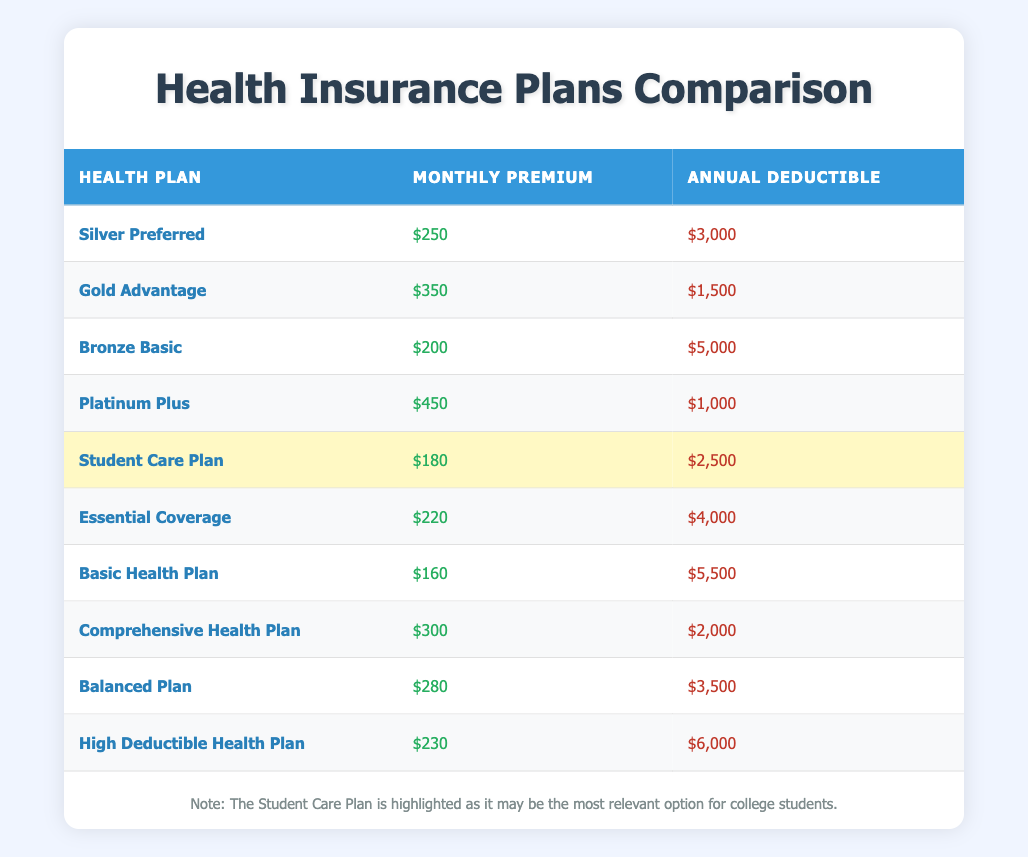What is the monthly premium for the Gold Advantage plan? The Gold Advantage plan has a specific entry in the table that shows its monthly premium, which is clearly listed as $350.
Answer: 350 Which plan has the highest annual deductible? The table provides a listing of all plans along with their annual deductibles. The plan with the highest deductible listed is the Basic Health Plan, with an annual deductible of $5,500.
Answer: Basic Health Plan What is the difference in monthly premium between Platinum Plus and Bronze Basic? To find the difference, take the monthly premium of Platinum Plus ($450) and subtract the monthly premium of Bronze Basic ($200). This gives $450 - $200 = $250 as the difference.
Answer: 250 Is the Student Care Plan cheaper than the Comprehensive Health Plan in terms of monthly premium? By comparing the monthly premiums directly in the table, the Student Care Plan costs $180 while the Comprehensive Health Plan costs $300. Since $180 is less than $300, it confirms that the Student Care Plan is cheaper.
Answer: Yes What is the average annual deductible across all the plans listed? First, sum all the annual deductibles: 3000 + 1500 + 5000 + 1000 + 2500 + 4000 + 5500 + 2000 + 3500 + 6000 = 30500. There are 10 plans in total, so divide the sum by 10: 30500 / 10 = 3050.
Answer: 3050 Which health plan has the lowest deductible amount? By reviewing the annual deductibles listed in the table, the plan with the lowest deductible is the Platinum Plus with an annual deductible of $1,000.
Answer: Platinum Plus Does the Balanced Plan have a higher premium than the Essential Coverage plan? Comparing the monthly premiums directly from the table, the Balanced Plan has a premium of $280 and the Essential Coverage has a premium of $220. Since $280 is greater than $220, the Balanced Plan does indeed have a higher premium.
Answer: Yes What is the total monthly premium of the three cheapest plans? Identify the three cheapest plans from the list: Basic Health Plan ($160), Student Care Plan ($180), and Bronze Basic ($200). Adding their monthly premiums gives: $160 + $180 + $200 = $540.
Answer: 540 Is the Platinum Plus plan both the most expensive in terms of monthly premium and has a low deductible? The Platinum Plus plan has the highest monthly premium ($450) but also has a relatively low deductible of $1,000. To confirm, check that no other plan has both a higher premium and a lower deductible than that. So yes, it qualifies as most expensive while maintaining a low deductible.
Answer: Yes 